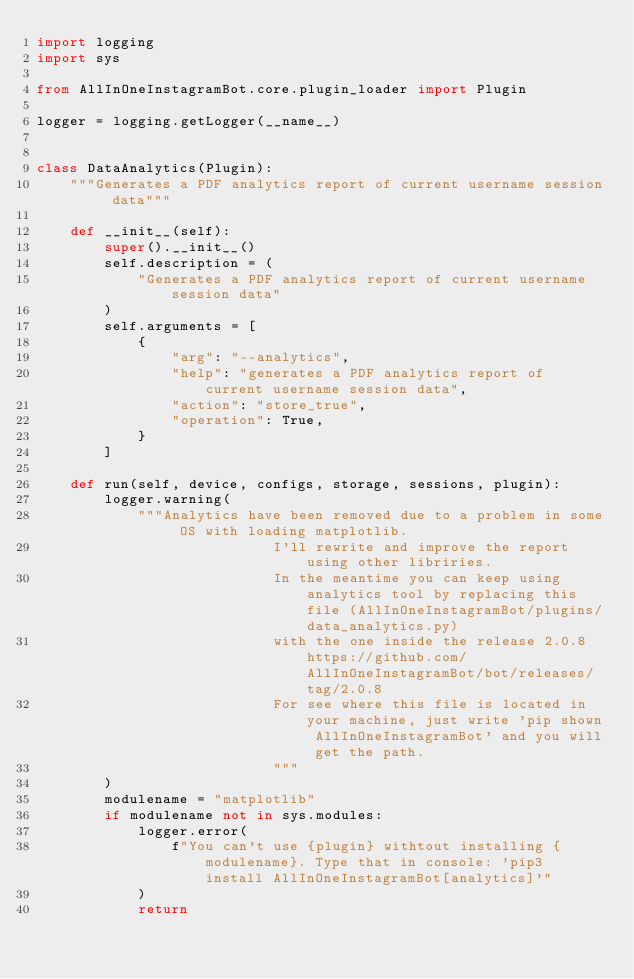Convert code to text. <code><loc_0><loc_0><loc_500><loc_500><_Python_>import logging
import sys

from AllInOneInstagramBot.core.plugin_loader import Plugin

logger = logging.getLogger(__name__)


class DataAnalytics(Plugin):
    """Generates a PDF analytics report of current username session data"""

    def __init__(self):
        super().__init__()
        self.description = (
            "Generates a PDF analytics report of current username session data"
        )
        self.arguments = [
            {
                "arg": "--analytics",
                "help": "generates a PDF analytics report of current username session data",
                "action": "store_true",
                "operation": True,
            }
        ]

    def run(self, device, configs, storage, sessions, plugin):
        logger.warning(
            """Analytics have been removed due to a problem in some OS with loading matplotlib.
                            I'll rewrite and improve the report using other libriries.
                            In the meantime you can keep using analytics tool by replacing this file (AllInOneInstagramBot/plugins/data_analytics.py)
                            with the one inside the release 2.0.8 https://github.com/AllInOneInstagramBot/bot/releases/tag/2.0.8
                            For see where this file is located in your machine, just write 'pip shown AllInOneInstagramBot' and you will get the path.
                            """
        )
        modulename = "matplotlib"
        if modulename not in sys.modules:
            logger.error(
                f"You can't use {plugin} withtout installing {modulename}. Type that in console: 'pip3 install AllInOneInstagramBot[analytics]'"
            )
            return
</code> 